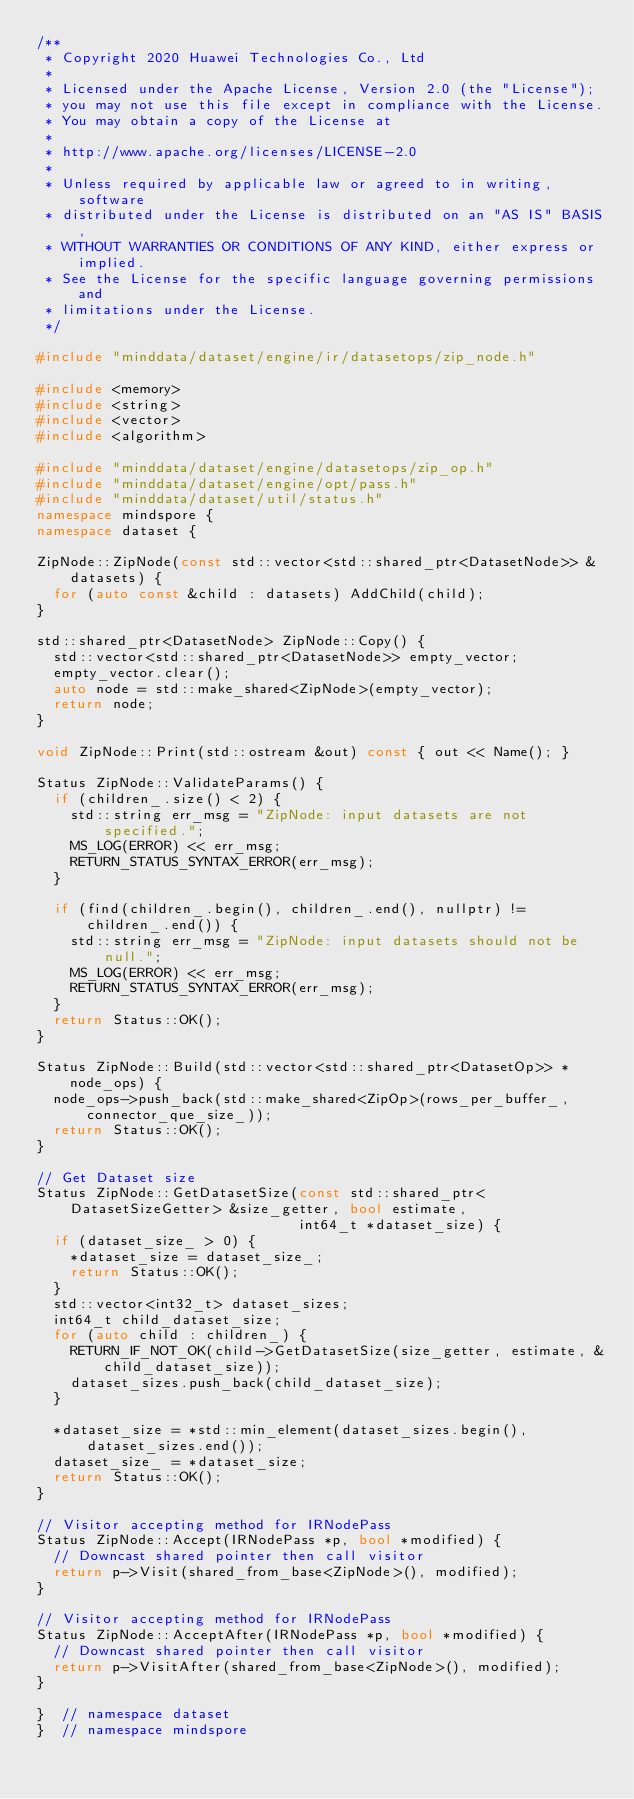Convert code to text. <code><loc_0><loc_0><loc_500><loc_500><_C++_>/**
 * Copyright 2020 Huawei Technologies Co., Ltd
 *
 * Licensed under the Apache License, Version 2.0 (the "License");
 * you may not use this file except in compliance with the License.
 * You may obtain a copy of the License at
 *
 * http://www.apache.org/licenses/LICENSE-2.0
 *
 * Unless required by applicable law or agreed to in writing, software
 * distributed under the License is distributed on an "AS IS" BASIS,
 * WITHOUT WARRANTIES OR CONDITIONS OF ANY KIND, either express or implied.
 * See the License for the specific language governing permissions and
 * limitations under the License.
 */

#include "minddata/dataset/engine/ir/datasetops/zip_node.h"

#include <memory>
#include <string>
#include <vector>
#include <algorithm>

#include "minddata/dataset/engine/datasetops/zip_op.h"
#include "minddata/dataset/engine/opt/pass.h"
#include "minddata/dataset/util/status.h"
namespace mindspore {
namespace dataset {

ZipNode::ZipNode(const std::vector<std::shared_ptr<DatasetNode>> &datasets) {
  for (auto const &child : datasets) AddChild(child);
}

std::shared_ptr<DatasetNode> ZipNode::Copy() {
  std::vector<std::shared_ptr<DatasetNode>> empty_vector;
  empty_vector.clear();
  auto node = std::make_shared<ZipNode>(empty_vector);
  return node;
}

void ZipNode::Print(std::ostream &out) const { out << Name(); }

Status ZipNode::ValidateParams() {
  if (children_.size() < 2) {
    std::string err_msg = "ZipNode: input datasets are not specified.";
    MS_LOG(ERROR) << err_msg;
    RETURN_STATUS_SYNTAX_ERROR(err_msg);
  }

  if (find(children_.begin(), children_.end(), nullptr) != children_.end()) {
    std::string err_msg = "ZipNode: input datasets should not be null.";
    MS_LOG(ERROR) << err_msg;
    RETURN_STATUS_SYNTAX_ERROR(err_msg);
  }
  return Status::OK();
}

Status ZipNode::Build(std::vector<std::shared_ptr<DatasetOp>> *node_ops) {
  node_ops->push_back(std::make_shared<ZipOp>(rows_per_buffer_, connector_que_size_));
  return Status::OK();
}

// Get Dataset size
Status ZipNode::GetDatasetSize(const std::shared_ptr<DatasetSizeGetter> &size_getter, bool estimate,
                               int64_t *dataset_size) {
  if (dataset_size_ > 0) {
    *dataset_size = dataset_size_;
    return Status::OK();
  }
  std::vector<int32_t> dataset_sizes;
  int64_t child_dataset_size;
  for (auto child : children_) {
    RETURN_IF_NOT_OK(child->GetDatasetSize(size_getter, estimate, &child_dataset_size));
    dataset_sizes.push_back(child_dataset_size);
  }

  *dataset_size = *std::min_element(dataset_sizes.begin(), dataset_sizes.end());
  dataset_size_ = *dataset_size;
  return Status::OK();
}

// Visitor accepting method for IRNodePass
Status ZipNode::Accept(IRNodePass *p, bool *modified) {
  // Downcast shared pointer then call visitor
  return p->Visit(shared_from_base<ZipNode>(), modified);
}

// Visitor accepting method for IRNodePass
Status ZipNode::AcceptAfter(IRNodePass *p, bool *modified) {
  // Downcast shared pointer then call visitor
  return p->VisitAfter(shared_from_base<ZipNode>(), modified);
}

}  // namespace dataset
}  // namespace mindspore
</code> 